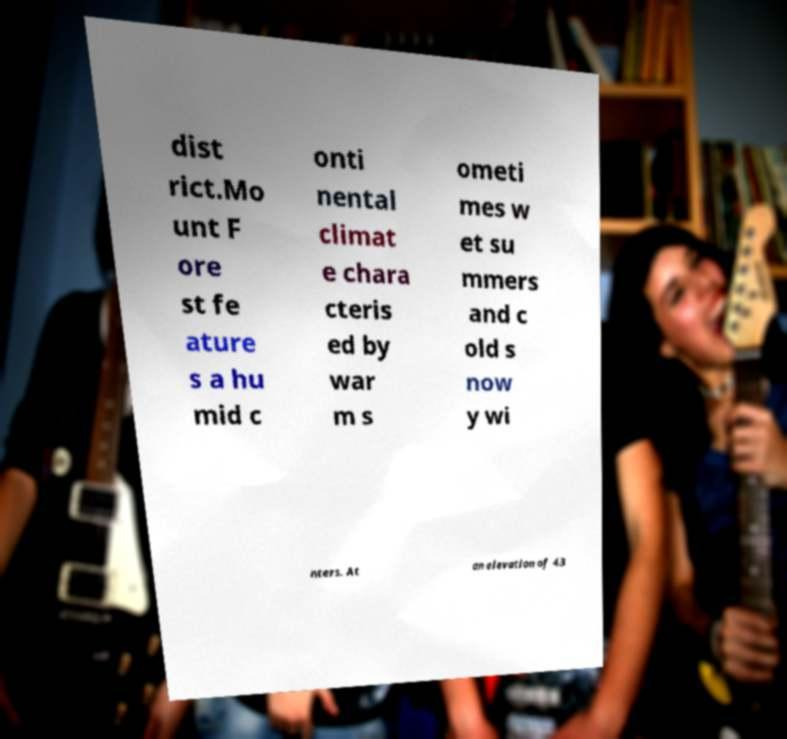Please read and relay the text visible in this image. What does it say? dist rict.Mo unt F ore st fe ature s a hu mid c onti nental climat e chara cteris ed by war m s ometi mes w et su mmers and c old s now y wi nters. At an elevation of 43 